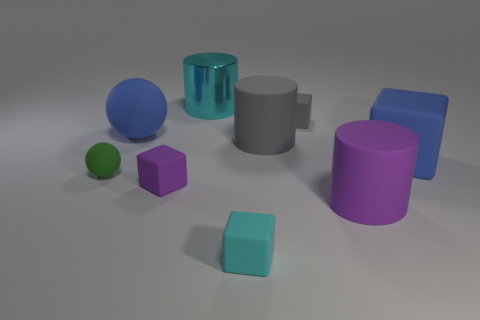How many cubes are both to the right of the small purple thing and behind the cyan cube?
Ensure brevity in your answer.  2. There is a purple object that is the same shape as the tiny gray matte thing; what is its size?
Your answer should be compact. Small. What number of big blue things have the same material as the cyan cylinder?
Offer a terse response. 0. Are there fewer tiny balls that are on the right side of the tiny purple matte block than red metal cylinders?
Your answer should be compact. No. What number of tiny cylinders are there?
Your answer should be compact. 0. What number of other matte blocks are the same color as the large rubber cube?
Your response must be concise. 0. Do the small gray thing and the big gray object have the same shape?
Your answer should be very brief. No. There is a gray matte object in front of the big blue rubber thing that is left of the big gray matte thing; what is its size?
Your response must be concise. Large. Are there any blue spheres that have the same size as the gray block?
Make the answer very short. No. Do the cyan object that is behind the green ball and the rubber sphere in front of the big blue block have the same size?
Make the answer very short. No. 